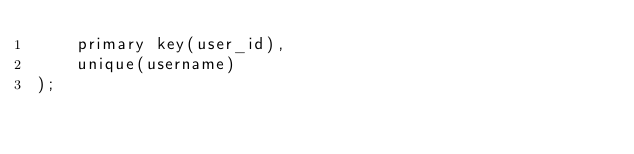Convert code to text. <code><loc_0><loc_0><loc_500><loc_500><_SQL_>    primary key(user_id),
    unique(username)
);
</code> 